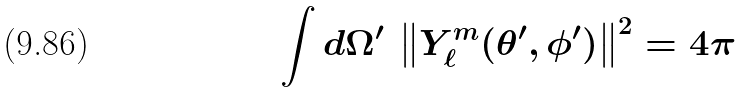<formula> <loc_0><loc_0><loc_500><loc_500>\int d \Omega ^ { \prime } \, \left \| Y _ { \ell } ^ { m } ( \theta ^ { \prime } , \phi ^ { \prime } ) \right \| ^ { 2 } = 4 \pi</formula> 